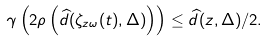<formula> <loc_0><loc_0><loc_500><loc_500>\gamma \left ( 2 \rho \left ( \widehat { d } ( \zeta _ { z \omega } ( t ) , \Delta ) \right ) \right ) \leq \widehat { d } ( z , \Delta ) / 2 .</formula> 